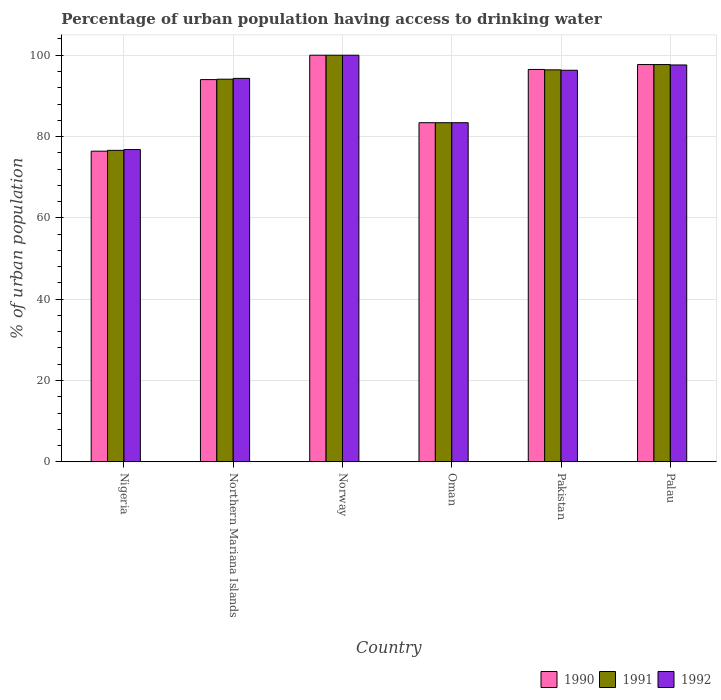How many different coloured bars are there?
Ensure brevity in your answer.  3. Are the number of bars per tick equal to the number of legend labels?
Your response must be concise. Yes. Are the number of bars on each tick of the X-axis equal?
Provide a short and direct response. Yes. How many bars are there on the 3rd tick from the right?
Keep it short and to the point. 3. What is the label of the 6th group of bars from the left?
Your answer should be compact. Palau. In how many cases, is the number of bars for a given country not equal to the number of legend labels?
Provide a succinct answer. 0. What is the percentage of urban population having access to drinking water in 1990 in Pakistan?
Keep it short and to the point. 96.5. Across all countries, what is the minimum percentage of urban population having access to drinking water in 1991?
Ensure brevity in your answer.  76.6. In which country was the percentage of urban population having access to drinking water in 1991 maximum?
Provide a succinct answer. Norway. In which country was the percentage of urban population having access to drinking water in 1990 minimum?
Your answer should be compact. Nigeria. What is the total percentage of urban population having access to drinking water in 1992 in the graph?
Provide a succinct answer. 548.4. What is the difference between the percentage of urban population having access to drinking water in 1991 in Northern Mariana Islands and that in Palau?
Provide a short and direct response. -3.6. What is the difference between the percentage of urban population having access to drinking water in 1992 in Norway and the percentage of urban population having access to drinking water in 1990 in Pakistan?
Offer a terse response. 3.5. What is the average percentage of urban population having access to drinking water in 1991 per country?
Provide a short and direct response. 91.37. What is the difference between the percentage of urban population having access to drinking water of/in 1990 and percentage of urban population having access to drinking water of/in 1991 in Northern Mariana Islands?
Make the answer very short. -0.1. What is the ratio of the percentage of urban population having access to drinking water in 1991 in Nigeria to that in Norway?
Your answer should be compact. 0.77. What is the difference between the highest and the second highest percentage of urban population having access to drinking water in 1991?
Your answer should be compact. -1.3. What is the difference between the highest and the lowest percentage of urban population having access to drinking water in 1990?
Your answer should be very brief. 23.6. Is the sum of the percentage of urban population having access to drinking water in 1992 in Nigeria and Palau greater than the maximum percentage of urban population having access to drinking water in 1990 across all countries?
Your answer should be compact. Yes. What is the difference between two consecutive major ticks on the Y-axis?
Give a very brief answer. 20. Where does the legend appear in the graph?
Your response must be concise. Bottom right. How many legend labels are there?
Give a very brief answer. 3. How are the legend labels stacked?
Offer a terse response. Horizontal. What is the title of the graph?
Provide a short and direct response. Percentage of urban population having access to drinking water. Does "2004" appear as one of the legend labels in the graph?
Keep it short and to the point. No. What is the label or title of the X-axis?
Your answer should be compact. Country. What is the label or title of the Y-axis?
Your response must be concise. % of urban population. What is the % of urban population of 1990 in Nigeria?
Provide a short and direct response. 76.4. What is the % of urban population in 1991 in Nigeria?
Offer a terse response. 76.6. What is the % of urban population of 1992 in Nigeria?
Provide a short and direct response. 76.8. What is the % of urban population of 1990 in Northern Mariana Islands?
Provide a succinct answer. 94. What is the % of urban population of 1991 in Northern Mariana Islands?
Your response must be concise. 94.1. What is the % of urban population in 1992 in Northern Mariana Islands?
Provide a succinct answer. 94.3. What is the % of urban population in 1990 in Norway?
Keep it short and to the point. 100. What is the % of urban population in 1990 in Oman?
Make the answer very short. 83.4. What is the % of urban population in 1991 in Oman?
Provide a succinct answer. 83.4. What is the % of urban population in 1992 in Oman?
Keep it short and to the point. 83.4. What is the % of urban population of 1990 in Pakistan?
Your response must be concise. 96.5. What is the % of urban population of 1991 in Pakistan?
Keep it short and to the point. 96.4. What is the % of urban population in 1992 in Pakistan?
Offer a terse response. 96.3. What is the % of urban population in 1990 in Palau?
Your response must be concise. 97.7. What is the % of urban population in 1991 in Palau?
Keep it short and to the point. 97.7. What is the % of urban population of 1992 in Palau?
Offer a terse response. 97.6. Across all countries, what is the maximum % of urban population in 1991?
Offer a very short reply. 100. Across all countries, what is the minimum % of urban population in 1990?
Provide a succinct answer. 76.4. Across all countries, what is the minimum % of urban population of 1991?
Offer a terse response. 76.6. Across all countries, what is the minimum % of urban population in 1992?
Your response must be concise. 76.8. What is the total % of urban population of 1990 in the graph?
Keep it short and to the point. 548. What is the total % of urban population of 1991 in the graph?
Provide a succinct answer. 548.2. What is the total % of urban population in 1992 in the graph?
Offer a terse response. 548.4. What is the difference between the % of urban population of 1990 in Nigeria and that in Northern Mariana Islands?
Offer a terse response. -17.6. What is the difference between the % of urban population in 1991 in Nigeria and that in Northern Mariana Islands?
Your answer should be compact. -17.5. What is the difference between the % of urban population of 1992 in Nigeria and that in Northern Mariana Islands?
Your response must be concise. -17.5. What is the difference between the % of urban population in 1990 in Nigeria and that in Norway?
Provide a succinct answer. -23.6. What is the difference between the % of urban population of 1991 in Nigeria and that in Norway?
Give a very brief answer. -23.4. What is the difference between the % of urban population of 1992 in Nigeria and that in Norway?
Give a very brief answer. -23.2. What is the difference between the % of urban population of 1990 in Nigeria and that in Oman?
Ensure brevity in your answer.  -7. What is the difference between the % of urban population in 1991 in Nigeria and that in Oman?
Offer a terse response. -6.8. What is the difference between the % of urban population of 1990 in Nigeria and that in Pakistan?
Your answer should be very brief. -20.1. What is the difference between the % of urban population of 1991 in Nigeria and that in Pakistan?
Your response must be concise. -19.8. What is the difference between the % of urban population of 1992 in Nigeria and that in Pakistan?
Your answer should be very brief. -19.5. What is the difference between the % of urban population of 1990 in Nigeria and that in Palau?
Offer a very short reply. -21.3. What is the difference between the % of urban population of 1991 in Nigeria and that in Palau?
Provide a short and direct response. -21.1. What is the difference between the % of urban population of 1992 in Nigeria and that in Palau?
Give a very brief answer. -20.8. What is the difference between the % of urban population in 1990 in Northern Mariana Islands and that in Norway?
Provide a succinct answer. -6. What is the difference between the % of urban population in 1990 in Northern Mariana Islands and that in Oman?
Offer a terse response. 10.6. What is the difference between the % of urban population of 1991 in Northern Mariana Islands and that in Pakistan?
Provide a short and direct response. -2.3. What is the difference between the % of urban population in 1992 in Northern Mariana Islands and that in Palau?
Provide a succinct answer. -3.3. What is the difference between the % of urban population in 1992 in Norway and that in Pakistan?
Your answer should be compact. 3.7. What is the difference between the % of urban population of 1990 in Norway and that in Palau?
Offer a very short reply. 2.3. What is the difference between the % of urban population in 1991 in Norway and that in Palau?
Keep it short and to the point. 2.3. What is the difference between the % of urban population of 1992 in Norway and that in Palau?
Your answer should be very brief. 2.4. What is the difference between the % of urban population in 1990 in Oman and that in Pakistan?
Your answer should be compact. -13.1. What is the difference between the % of urban population of 1991 in Oman and that in Pakistan?
Your answer should be very brief. -13. What is the difference between the % of urban population of 1992 in Oman and that in Pakistan?
Provide a succinct answer. -12.9. What is the difference between the % of urban population of 1990 in Oman and that in Palau?
Provide a succinct answer. -14.3. What is the difference between the % of urban population of 1991 in Oman and that in Palau?
Ensure brevity in your answer.  -14.3. What is the difference between the % of urban population of 1990 in Pakistan and that in Palau?
Make the answer very short. -1.2. What is the difference between the % of urban population in 1992 in Pakistan and that in Palau?
Ensure brevity in your answer.  -1.3. What is the difference between the % of urban population in 1990 in Nigeria and the % of urban population in 1991 in Northern Mariana Islands?
Offer a very short reply. -17.7. What is the difference between the % of urban population in 1990 in Nigeria and the % of urban population in 1992 in Northern Mariana Islands?
Offer a very short reply. -17.9. What is the difference between the % of urban population in 1991 in Nigeria and the % of urban population in 1992 in Northern Mariana Islands?
Your answer should be very brief. -17.7. What is the difference between the % of urban population of 1990 in Nigeria and the % of urban population of 1991 in Norway?
Provide a short and direct response. -23.6. What is the difference between the % of urban population in 1990 in Nigeria and the % of urban population in 1992 in Norway?
Make the answer very short. -23.6. What is the difference between the % of urban population of 1991 in Nigeria and the % of urban population of 1992 in Norway?
Make the answer very short. -23.4. What is the difference between the % of urban population in 1990 in Nigeria and the % of urban population in 1991 in Oman?
Your response must be concise. -7. What is the difference between the % of urban population of 1991 in Nigeria and the % of urban population of 1992 in Oman?
Provide a succinct answer. -6.8. What is the difference between the % of urban population in 1990 in Nigeria and the % of urban population in 1992 in Pakistan?
Make the answer very short. -19.9. What is the difference between the % of urban population of 1991 in Nigeria and the % of urban population of 1992 in Pakistan?
Your answer should be very brief. -19.7. What is the difference between the % of urban population in 1990 in Nigeria and the % of urban population in 1991 in Palau?
Provide a short and direct response. -21.3. What is the difference between the % of urban population in 1990 in Nigeria and the % of urban population in 1992 in Palau?
Your answer should be very brief. -21.2. What is the difference between the % of urban population of 1991 in Northern Mariana Islands and the % of urban population of 1992 in Norway?
Ensure brevity in your answer.  -5.9. What is the difference between the % of urban population of 1990 in Northern Mariana Islands and the % of urban population of 1992 in Oman?
Your answer should be compact. 10.6. What is the difference between the % of urban population of 1990 in Northern Mariana Islands and the % of urban population of 1991 in Palau?
Your answer should be very brief. -3.7. What is the difference between the % of urban population of 1991 in Norway and the % of urban population of 1992 in Oman?
Provide a succinct answer. 16.6. What is the difference between the % of urban population in 1990 in Norway and the % of urban population in 1991 in Pakistan?
Provide a succinct answer. 3.6. What is the difference between the % of urban population of 1990 in Norway and the % of urban population of 1992 in Pakistan?
Your answer should be very brief. 3.7. What is the difference between the % of urban population in 1990 in Oman and the % of urban population in 1991 in Pakistan?
Your answer should be compact. -13. What is the difference between the % of urban population in 1991 in Oman and the % of urban population in 1992 in Pakistan?
Offer a very short reply. -12.9. What is the difference between the % of urban population of 1990 in Oman and the % of urban population of 1991 in Palau?
Your response must be concise. -14.3. What is the difference between the % of urban population of 1990 in Oman and the % of urban population of 1992 in Palau?
Provide a short and direct response. -14.2. What is the difference between the % of urban population in 1990 in Pakistan and the % of urban population in 1991 in Palau?
Your response must be concise. -1.2. What is the average % of urban population of 1990 per country?
Your answer should be very brief. 91.33. What is the average % of urban population of 1991 per country?
Offer a terse response. 91.37. What is the average % of urban population of 1992 per country?
Your response must be concise. 91.4. What is the difference between the % of urban population of 1990 and % of urban population of 1992 in Nigeria?
Provide a succinct answer. -0.4. What is the difference between the % of urban population of 1991 and % of urban population of 1992 in Nigeria?
Ensure brevity in your answer.  -0.2. What is the difference between the % of urban population of 1990 and % of urban population of 1991 in Northern Mariana Islands?
Your response must be concise. -0.1. What is the difference between the % of urban population in 1991 and % of urban population in 1992 in Northern Mariana Islands?
Your answer should be very brief. -0.2. What is the difference between the % of urban population of 1990 and % of urban population of 1991 in Oman?
Provide a succinct answer. 0. What is the difference between the % of urban population in 1990 and % of urban population in 1992 in Pakistan?
Make the answer very short. 0.2. What is the difference between the % of urban population of 1991 and % of urban population of 1992 in Palau?
Provide a succinct answer. 0.1. What is the ratio of the % of urban population in 1990 in Nigeria to that in Northern Mariana Islands?
Keep it short and to the point. 0.81. What is the ratio of the % of urban population of 1991 in Nigeria to that in Northern Mariana Islands?
Make the answer very short. 0.81. What is the ratio of the % of urban population in 1992 in Nigeria to that in Northern Mariana Islands?
Your answer should be very brief. 0.81. What is the ratio of the % of urban population in 1990 in Nigeria to that in Norway?
Provide a short and direct response. 0.76. What is the ratio of the % of urban population in 1991 in Nigeria to that in Norway?
Offer a very short reply. 0.77. What is the ratio of the % of urban population of 1992 in Nigeria to that in Norway?
Offer a very short reply. 0.77. What is the ratio of the % of urban population of 1990 in Nigeria to that in Oman?
Provide a succinct answer. 0.92. What is the ratio of the % of urban population of 1991 in Nigeria to that in Oman?
Your answer should be compact. 0.92. What is the ratio of the % of urban population in 1992 in Nigeria to that in Oman?
Your answer should be compact. 0.92. What is the ratio of the % of urban population of 1990 in Nigeria to that in Pakistan?
Provide a succinct answer. 0.79. What is the ratio of the % of urban population of 1991 in Nigeria to that in Pakistan?
Your answer should be compact. 0.79. What is the ratio of the % of urban population of 1992 in Nigeria to that in Pakistan?
Your response must be concise. 0.8. What is the ratio of the % of urban population of 1990 in Nigeria to that in Palau?
Ensure brevity in your answer.  0.78. What is the ratio of the % of urban population of 1991 in Nigeria to that in Palau?
Offer a very short reply. 0.78. What is the ratio of the % of urban population of 1992 in Nigeria to that in Palau?
Offer a very short reply. 0.79. What is the ratio of the % of urban population of 1990 in Northern Mariana Islands to that in Norway?
Keep it short and to the point. 0.94. What is the ratio of the % of urban population of 1991 in Northern Mariana Islands to that in Norway?
Offer a very short reply. 0.94. What is the ratio of the % of urban population in 1992 in Northern Mariana Islands to that in Norway?
Provide a short and direct response. 0.94. What is the ratio of the % of urban population of 1990 in Northern Mariana Islands to that in Oman?
Offer a very short reply. 1.13. What is the ratio of the % of urban population in 1991 in Northern Mariana Islands to that in Oman?
Offer a very short reply. 1.13. What is the ratio of the % of urban population in 1992 in Northern Mariana Islands to that in Oman?
Give a very brief answer. 1.13. What is the ratio of the % of urban population of 1990 in Northern Mariana Islands to that in Pakistan?
Your answer should be very brief. 0.97. What is the ratio of the % of urban population in 1991 in Northern Mariana Islands to that in Pakistan?
Make the answer very short. 0.98. What is the ratio of the % of urban population in 1992 in Northern Mariana Islands to that in Pakistan?
Your answer should be compact. 0.98. What is the ratio of the % of urban population of 1990 in Northern Mariana Islands to that in Palau?
Provide a succinct answer. 0.96. What is the ratio of the % of urban population in 1991 in Northern Mariana Islands to that in Palau?
Your response must be concise. 0.96. What is the ratio of the % of urban population of 1992 in Northern Mariana Islands to that in Palau?
Ensure brevity in your answer.  0.97. What is the ratio of the % of urban population of 1990 in Norway to that in Oman?
Provide a succinct answer. 1.2. What is the ratio of the % of urban population in 1991 in Norway to that in Oman?
Provide a short and direct response. 1.2. What is the ratio of the % of urban population of 1992 in Norway to that in Oman?
Your answer should be compact. 1.2. What is the ratio of the % of urban population in 1990 in Norway to that in Pakistan?
Your response must be concise. 1.04. What is the ratio of the % of urban population in 1991 in Norway to that in Pakistan?
Make the answer very short. 1.04. What is the ratio of the % of urban population in 1992 in Norway to that in Pakistan?
Ensure brevity in your answer.  1.04. What is the ratio of the % of urban population of 1990 in Norway to that in Palau?
Your answer should be very brief. 1.02. What is the ratio of the % of urban population of 1991 in Norway to that in Palau?
Provide a short and direct response. 1.02. What is the ratio of the % of urban population in 1992 in Norway to that in Palau?
Give a very brief answer. 1.02. What is the ratio of the % of urban population in 1990 in Oman to that in Pakistan?
Offer a terse response. 0.86. What is the ratio of the % of urban population in 1991 in Oman to that in Pakistan?
Your response must be concise. 0.87. What is the ratio of the % of urban population in 1992 in Oman to that in Pakistan?
Make the answer very short. 0.87. What is the ratio of the % of urban population of 1990 in Oman to that in Palau?
Provide a succinct answer. 0.85. What is the ratio of the % of urban population of 1991 in Oman to that in Palau?
Give a very brief answer. 0.85. What is the ratio of the % of urban population in 1992 in Oman to that in Palau?
Keep it short and to the point. 0.85. What is the ratio of the % of urban population in 1990 in Pakistan to that in Palau?
Ensure brevity in your answer.  0.99. What is the ratio of the % of urban population of 1991 in Pakistan to that in Palau?
Your response must be concise. 0.99. What is the ratio of the % of urban population in 1992 in Pakistan to that in Palau?
Your answer should be compact. 0.99. What is the difference between the highest and the second highest % of urban population of 1992?
Make the answer very short. 2.4. What is the difference between the highest and the lowest % of urban population in 1990?
Provide a succinct answer. 23.6. What is the difference between the highest and the lowest % of urban population in 1991?
Your response must be concise. 23.4. What is the difference between the highest and the lowest % of urban population in 1992?
Your answer should be compact. 23.2. 